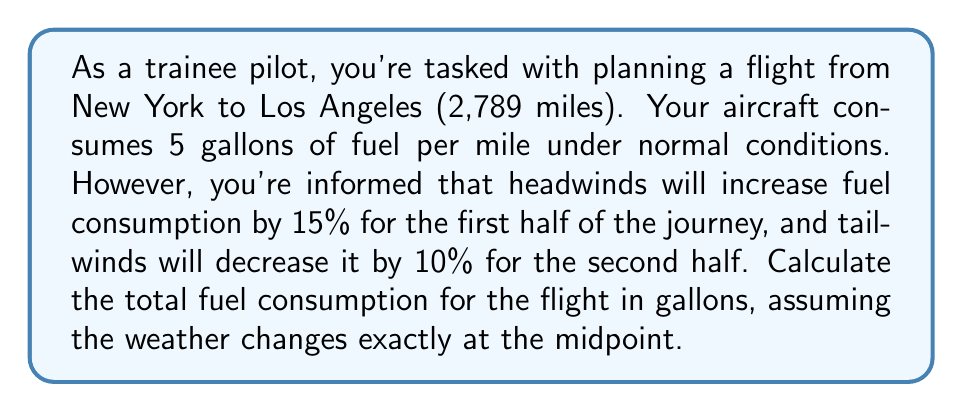Can you answer this question? Let's break this down step-by-step:

1) First, calculate the distance for each half of the journey:
   $$ \text{Half distance} = \frac{2,789}{2} = 1,394.5 \text{ miles} $$

2) Calculate fuel consumption for the first half (with headwinds):
   $$ \text{First half consumption} = 1,394.5 \times 5 \times 1.15 = 8,018.375 \text{ gallons} $$

3) Calculate fuel consumption for the second half (with tailwinds):
   $$ \text{Second half consumption} = 1,394.5 \times 5 \times 0.90 = 6,275.25 \text{ gallons} $$

4) Sum up the total fuel consumption:
   $$ \text{Total fuel} = 8,018.375 + 6,275.25 = 14,293.625 \text{ gallons} $$

5) Round to the nearest gallon:
   $$ \text{Total fuel (rounded)} = 14,294 \text{ gallons} $$
Answer: 14,294 gallons 